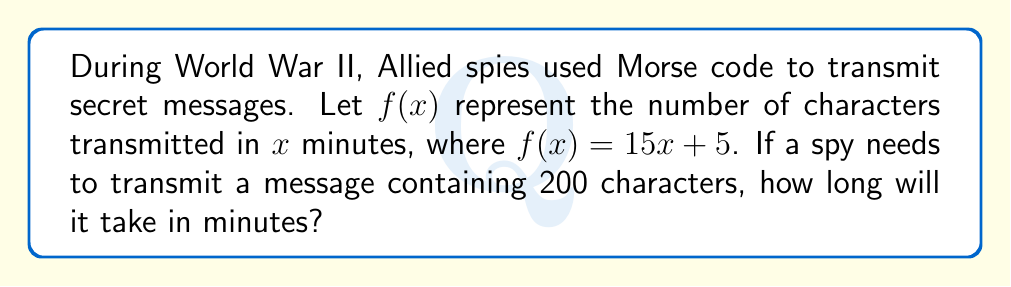Give your solution to this math problem. To solve this problem, we need to use the given function and find the inverse to determine the time required for a specific number of characters.

1) The given function is $f(x) = 15x + 5$, where:
   - $x$ is the time in minutes
   - $f(x)$ is the number of characters transmitted

2) We need to find $x$ when $f(x) = 200$. This means we need to solve the equation:

   $200 = 15x + 5$

3) Subtract 5 from both sides:
   
   $195 = 15x$

4) Divide both sides by 15:

   $13 = x$

5) Therefore, it will take 13 minutes to transmit 200 characters.

To verify:
$f(13) = 15(13) + 5 = 195 + 5 = 200$

This confirms our solution is correct.
Answer: It will take 13 minutes to transmit the 200-character message. 